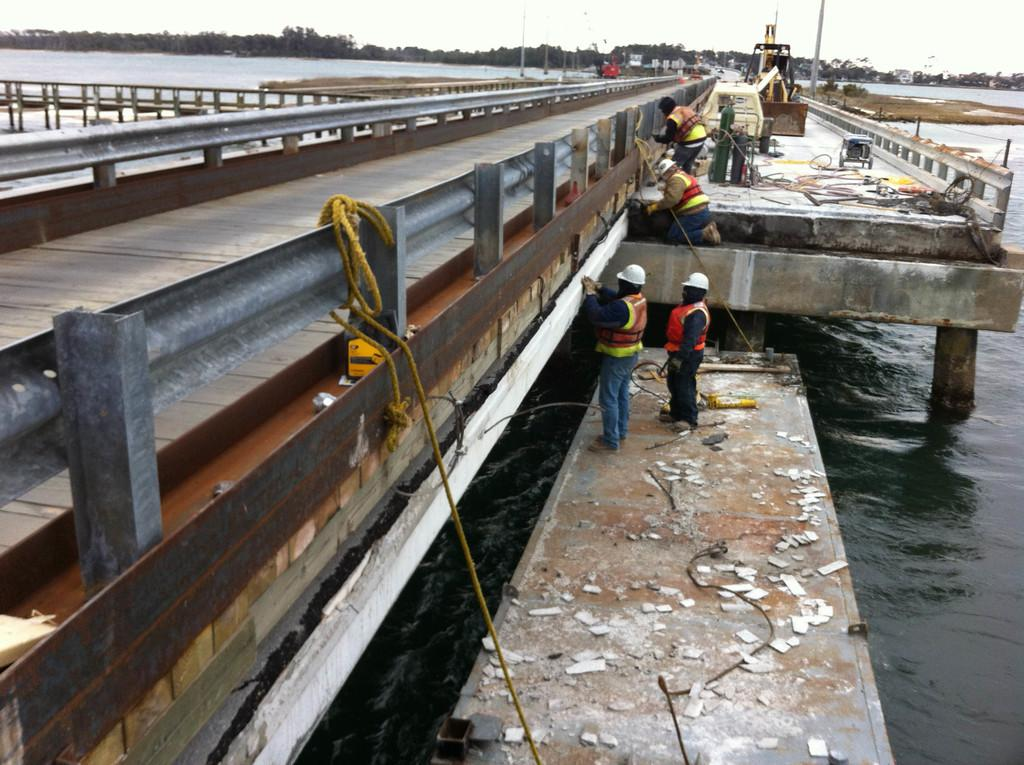What are the people in the image doing? The people in the image are standing and working. What type of machinery can be seen in the image? There is a crane in the image. What type of natural environment is visible in the image? There are trees visible in the image. What type of structures can be seen in the background of the image? There are buildings in the background of the image. What type of terrain is present in the image? Water is present in the image. What is the condition of the sky in the image? The sky is cloudy in the image. How many birds are sitting on the board in the image? There is no board or birds present in the image. What type of star can be seen shining in the image? There is no star visible in the image. 